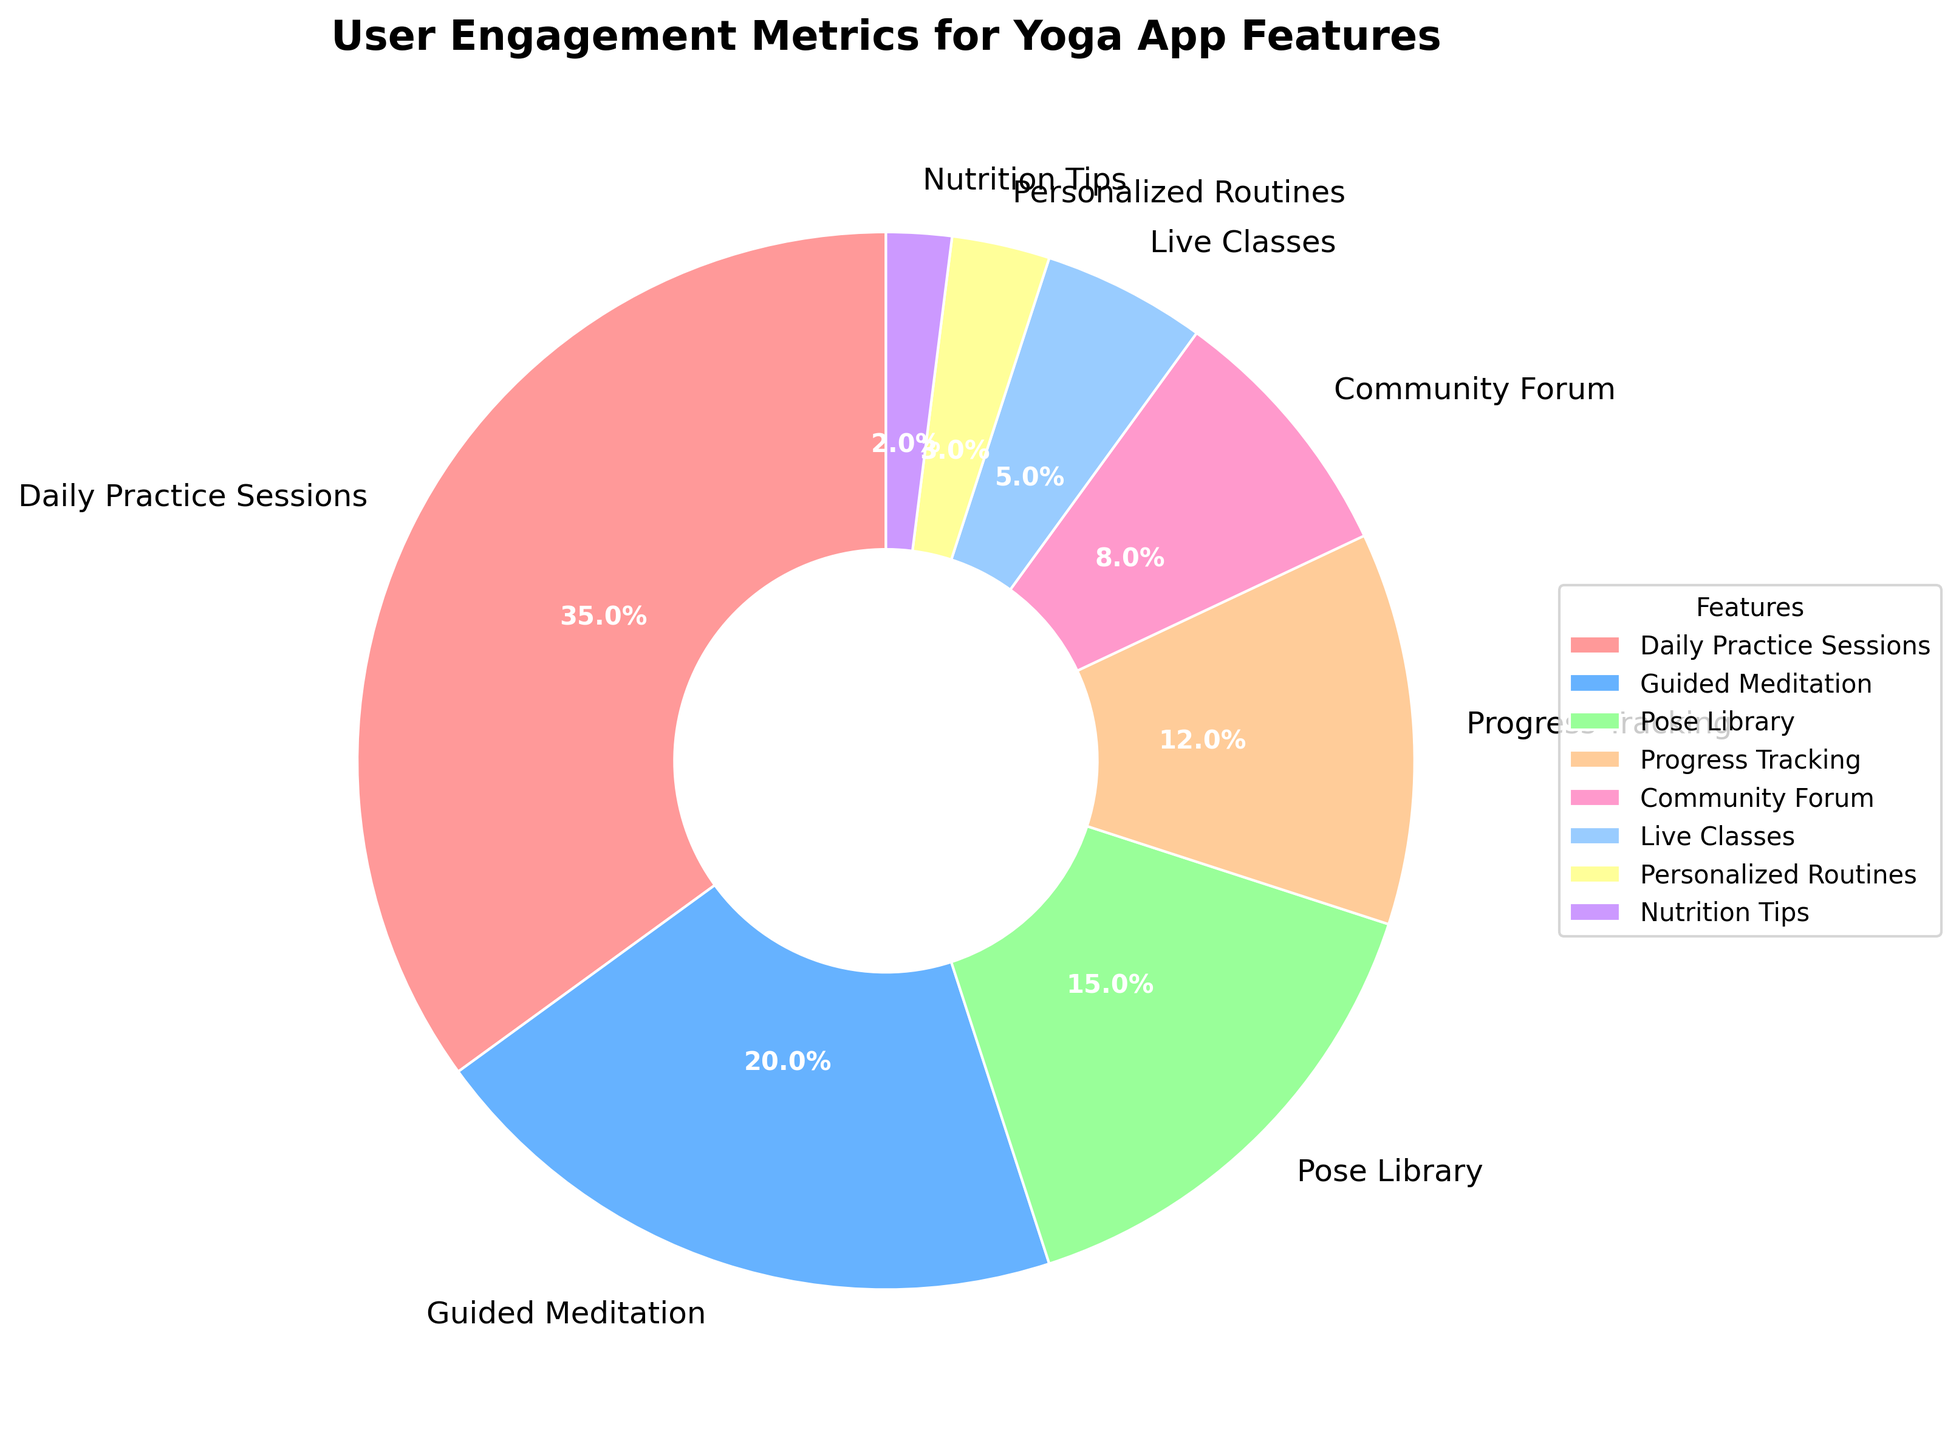What's the most engaging feature in the yoga app? The feature with the highest percentage slice in the pie chart represents the most engaging feature. By observing the chart, the "Daily Practice Sessions" takes up 35%, which is the largest segment.
Answer: Daily Practice Sessions Which feature has the least user engagement? The feature with the smallest percentage slice in the pie chart signifies the least user engagement. The smallest slice, representing 2%, corresponds to "Nutrition Tips".
Answer: Nutrition Tips How much higher is the engagement in Daily Practice Sessions compared to Live Classes? To find this, we subtract the percentage for Live Classes from Daily Practice Sessions: 35% - 5% = 30%. So, the engagement in Daily Practice Sessions is 30% higher than in Live Classes.
Answer: 30% What is the combined user engagement for Pose Library, Progress Tracking, and Community Forum? Adding the percentages of Pose Library (15%), Progress Tracking (12%), and Community Forum (8%) gives: 15% + 12% + 8% = 35%. Hence, their combined engagement is 35%.
Answer: 35% Does Personalized Routines have higher user engagement than Nutrition Tips? By comparing the percentages, Personalized Routines have 3% engagement whereas Nutrition Tips have 2%. Thus, Personalized Routines have higher engagement.
Answer: Yes What is the percentage difference between Guided Meditation and Pose Library? Subtracting the percentage of Pose Library from Guided Meditation gives: 20% - 15% = 5%. So, the percentage difference is 5%.
Answer: 5% Are there more users engaged in Progress Tracking or Community Forum? By visually comparing the slices, Progress Tracking represents 12% and Community Forum 8%. Therefore, more users are engaged in Progress Tracking.
Answer: Progress Tracking Which feature has a yellow slice in the pie chart? Observing the color yellow in the pie chart corresponds to the feature labeled "Pose Library", which has a 15% engagement slice.
Answer: Pose Library How much do the top two features contribute to the overall user engagement? Adding the percentages for the top two features: Daily Practice Sessions (35%) and Guided Meditation (20%): 35% + 20% = 55%. Thus, they contribute 55%.
Answer: 55% If you were to focus on improving the bottom three features, what is their combined user engagement percentage? Summing the percentages of the bottom three: Live Classes (5%), Personalized Routines (3%), and Nutrition Tips (2%) gives: 5% + 3% + 2% = 10%. Their combined engagement is 10%.
Answer: 10% 